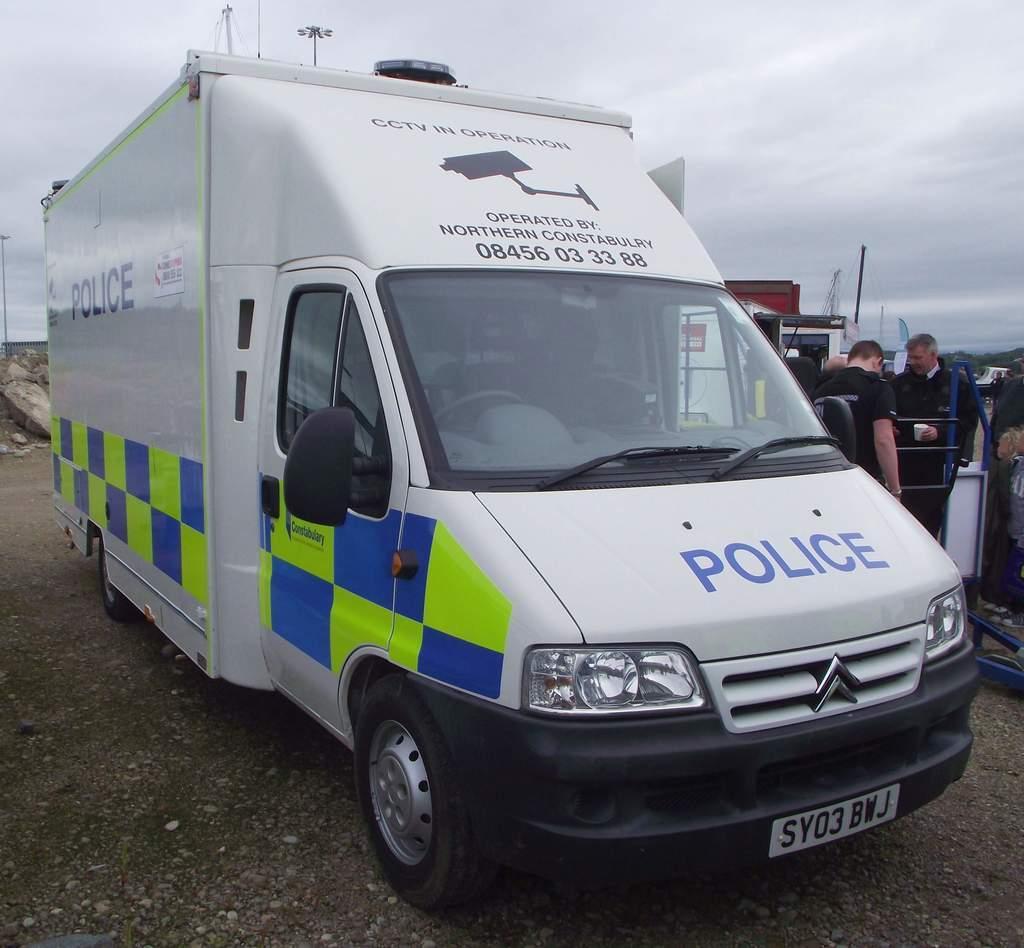Could you give a brief overview of what you see in this image? In this picture there is a police vehicle in the center of the image and there are people on the right side of the image and there are rocks, poles, and trees in the background area of the image. 